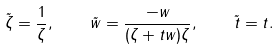<formula> <loc_0><loc_0><loc_500><loc_500>\tilde { \zeta } = \frac { 1 } { \zeta } , \quad \tilde { w } = \frac { - w } { ( \zeta + t w ) \zeta } , \quad \tilde { t } = t .</formula> 